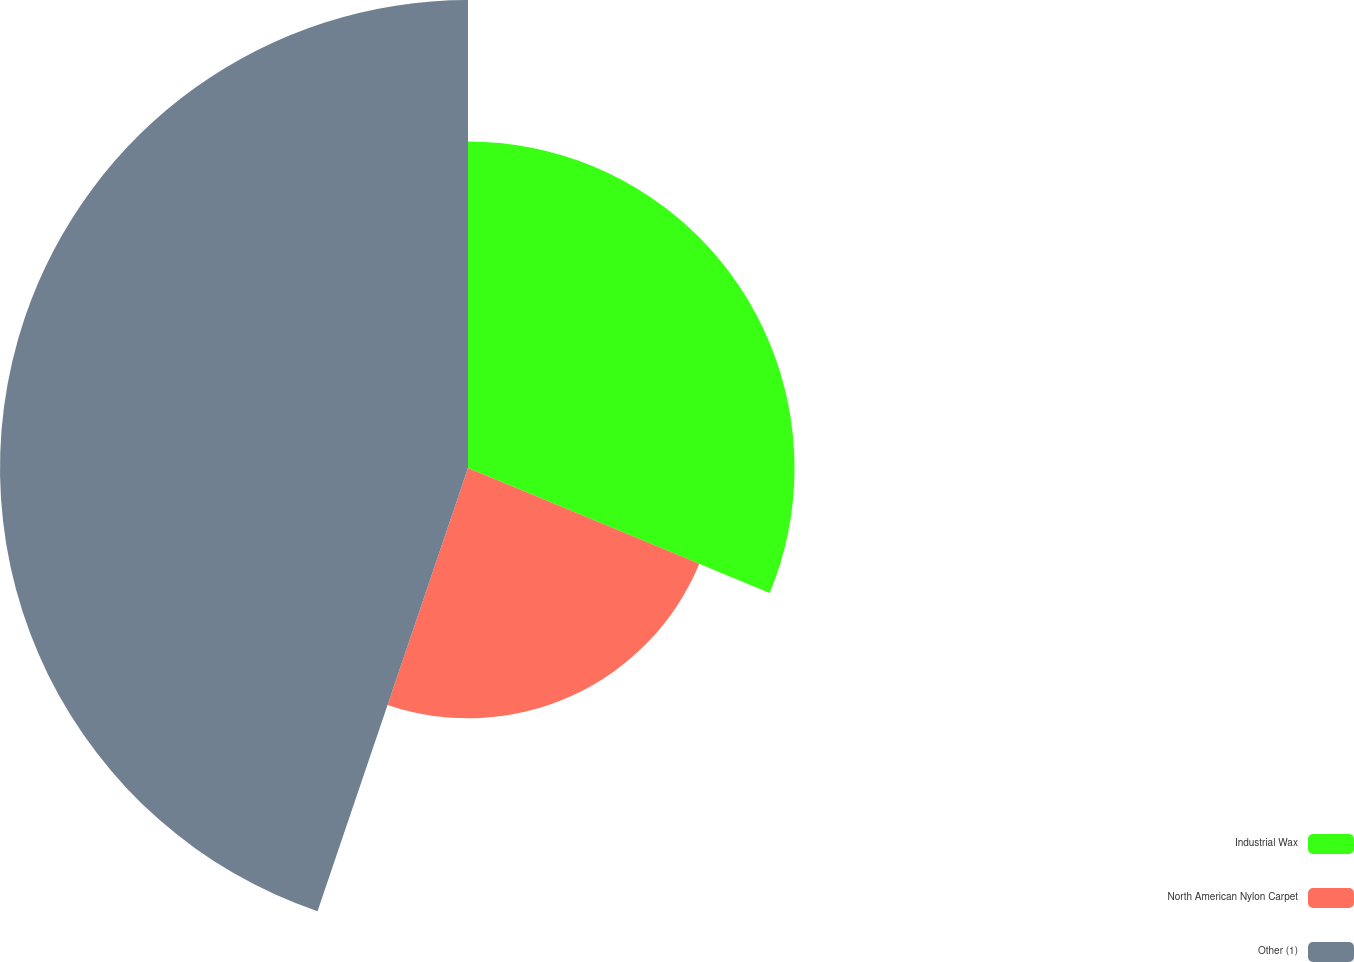Convert chart to OTSL. <chart><loc_0><loc_0><loc_500><loc_500><pie_chart><fcel>Industrial Wax<fcel>North American Nylon Carpet<fcel>Other (1)<nl><fcel>31.25%<fcel>23.96%<fcel>44.79%<nl></chart> 